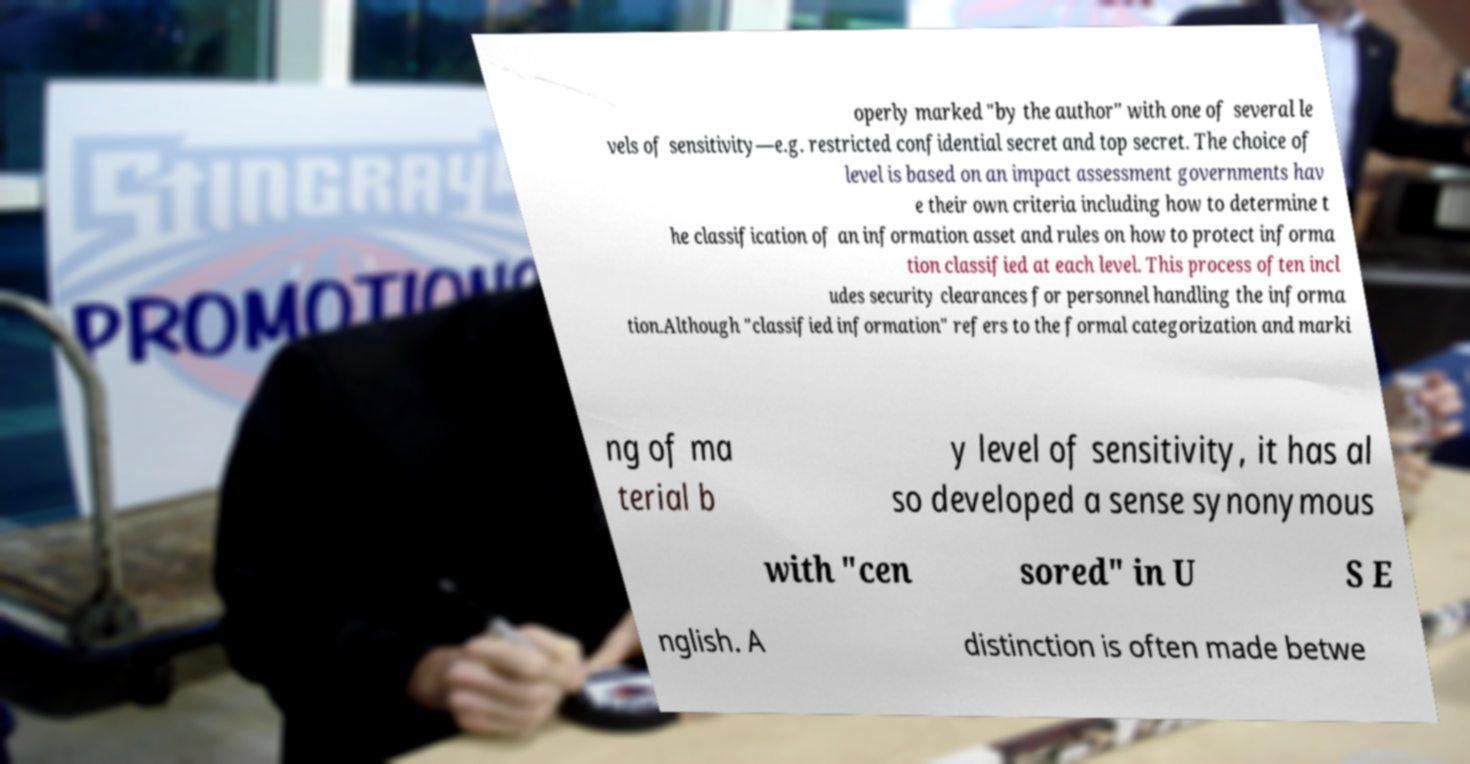Please identify and transcribe the text found in this image. operly marked "by the author" with one of several le vels of sensitivity—e.g. restricted confidential secret and top secret. The choice of level is based on an impact assessment governments hav e their own criteria including how to determine t he classification of an information asset and rules on how to protect informa tion classified at each level. This process often incl udes security clearances for personnel handling the informa tion.Although "classified information" refers to the formal categorization and marki ng of ma terial b y level of sensitivity, it has al so developed a sense synonymous with "cen sored" in U S E nglish. A distinction is often made betwe 